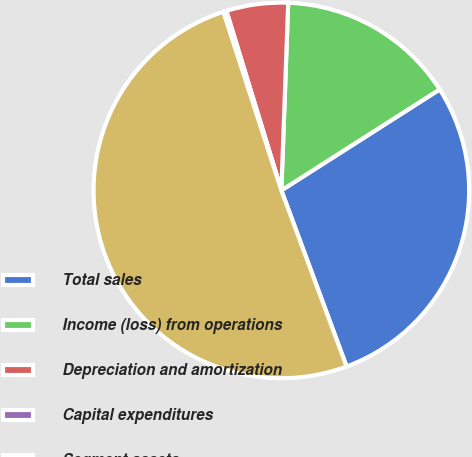Convert chart. <chart><loc_0><loc_0><loc_500><loc_500><pie_chart><fcel>Total sales<fcel>Income (loss) from operations<fcel>Depreciation and amortization<fcel>Capital expenditures<fcel>Segment assets<nl><fcel>28.39%<fcel>15.38%<fcel>5.31%<fcel>0.27%<fcel>50.64%<nl></chart> 